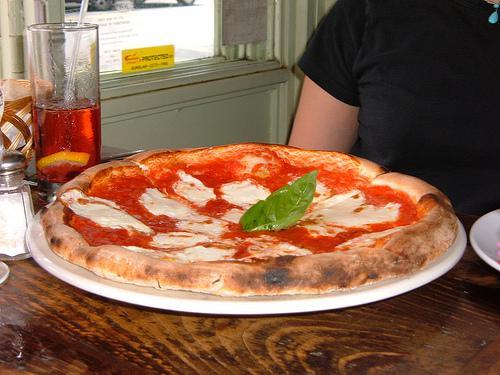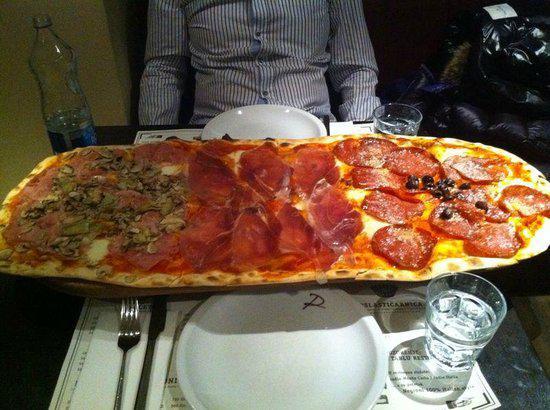The first image is the image on the left, the second image is the image on the right. For the images displayed, is the sentence "In one of the images, a very long pizza appears to have three sections, with different toppings in each of the sections." factually correct? Answer yes or no. Yes. The first image is the image on the left, the second image is the image on the right. Considering the images on both sides, is "The left image features someone sitting at a wooden table behind a round pizza, with a glass of amber beverage next to the pizza." valid? Answer yes or no. Yes. 